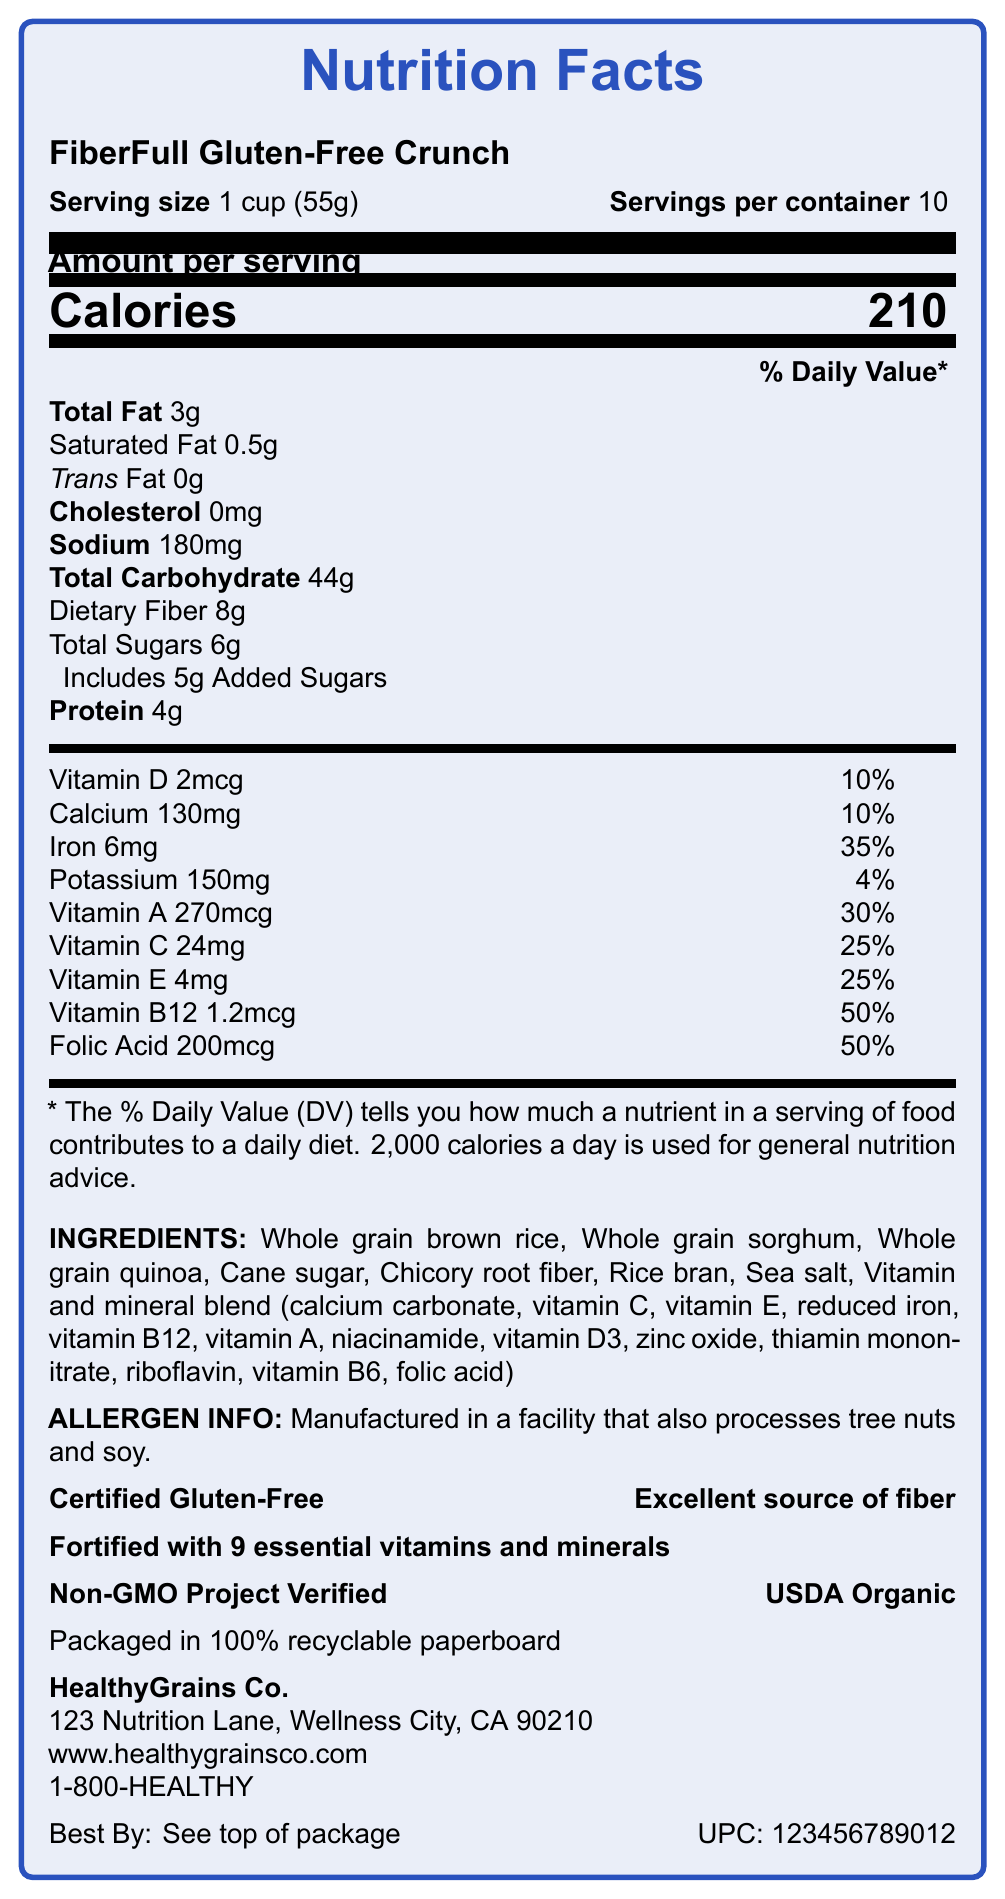what is the dietary fiber content per serving? According to the document, the dietary fiber content per serving is 8g.
Answer: 8g what is the serving size of FiberFull Gluten-Free Crunch? The document indicates that the serving size is 1 cup (55g).
Answer: 1 cup (55g) how many servings are there per container? The document states that there are 10 servings per container.
Answer: 10 what is the percentage of daily value for iron? The document specifies that the daily value for iron per serving is 35%.
Answer: 35% how much calcium is in one serving? The document shows that one serving contains 130mg of calcium.
Answer: 130mg which of the following vitamins has the highest percentage daily value per serving? A. Vitamin A B. Vitamin C C. Vitamin B12 The document lists Vitamin A at 30%, Vitamin C at 25%, and Vitamin B12 at 50%.
Answer: C. Vitamin B12 what is the amount of calories per serving? A. 180 B. 190 C. 210 D. 220 The document clearly states that the calorie content per serving is 210 calories.
Answer: C. 210 is FiberFull Gluten-Free Crunch certified gluten-free? According to the document, the product is certified gluten-free.
Answer: Yes provide a summary of the nutrition facts label for FiberFull Gluten-Free Crunch. The document provides a comprehensive overview of the nutritional content, including macronutrients, micronutrients, and other health claims.
Answer: The nutrition facts label for FiberFull Gluten-Free Crunch includes details on serving size (1 cup/55g), servings per container (10), calories per serving (210), and amounts of various nutrients like total fat (3g/4%), dietary fiber (8g/29%), and numerous vitamins and minerals. It highlights being gluten-free and having an excellent source of fiber, fortified with 9 essential vitamins and minerals, and certified organic and non-GMO. how much sodium is in one serving? The document indicates that one serving contains 180mg of sodium.
Answer: 180mg which ingredient appears first on the ingredients list? The first ingredient listed in the document is whole grain brown rice.
Answer: Whole grain brown rice what is the main source of fiber in this cereal? The document lists chicory root fiber as one of the ingredients.
Answer: Chicory root fiber does the cereal contain any trans fat? The document states that the cereal contains 0g of trans fat.
Answer: No who is the manufacturer of FiberFull Gluten-Free Crunch? The manufacturer listed in the document is HealthyGrains Co.
Answer: HealthyGrains Co. what is the daily value percentage of Vitamin A? The document specifies that the daily value percentage of Vitamin A is 30%.
Answer: 30% is this product non-GMO? The document clearly states that the product is Non-GMO Project Verified.
Answer: Yes how many added sugars are in one serving of FiberFull Gluten-Free Crunch? The document specifies that there are 5g of added sugars per serving.
Answer: 5g how much vitamin E is included in each serving? According to the document, each serving includes 4mg of vitamin E.
Answer: 4mg where is FiberFull Gluten-Free Crunch manufactured? The document does not provide specific information about the manufacturing location, only the address of the company headquarters.
Answer: Cannot be determined 